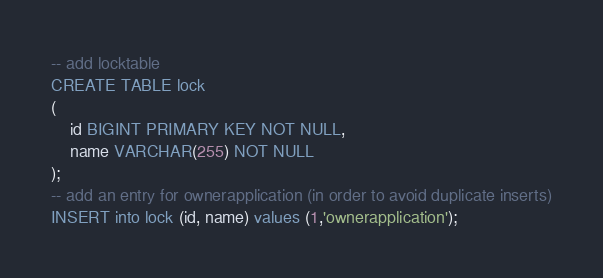Convert code to text. <code><loc_0><loc_0><loc_500><loc_500><_SQL_>-- add locktable
CREATE TABLE lock
(
    id BIGINT PRIMARY KEY NOT NULL,
    name VARCHAR(255) NOT NULL
);
-- add an entry for ownerapplication (in order to avoid duplicate inserts)
INSERT into lock (id, name) values (1,'ownerapplication');</code> 